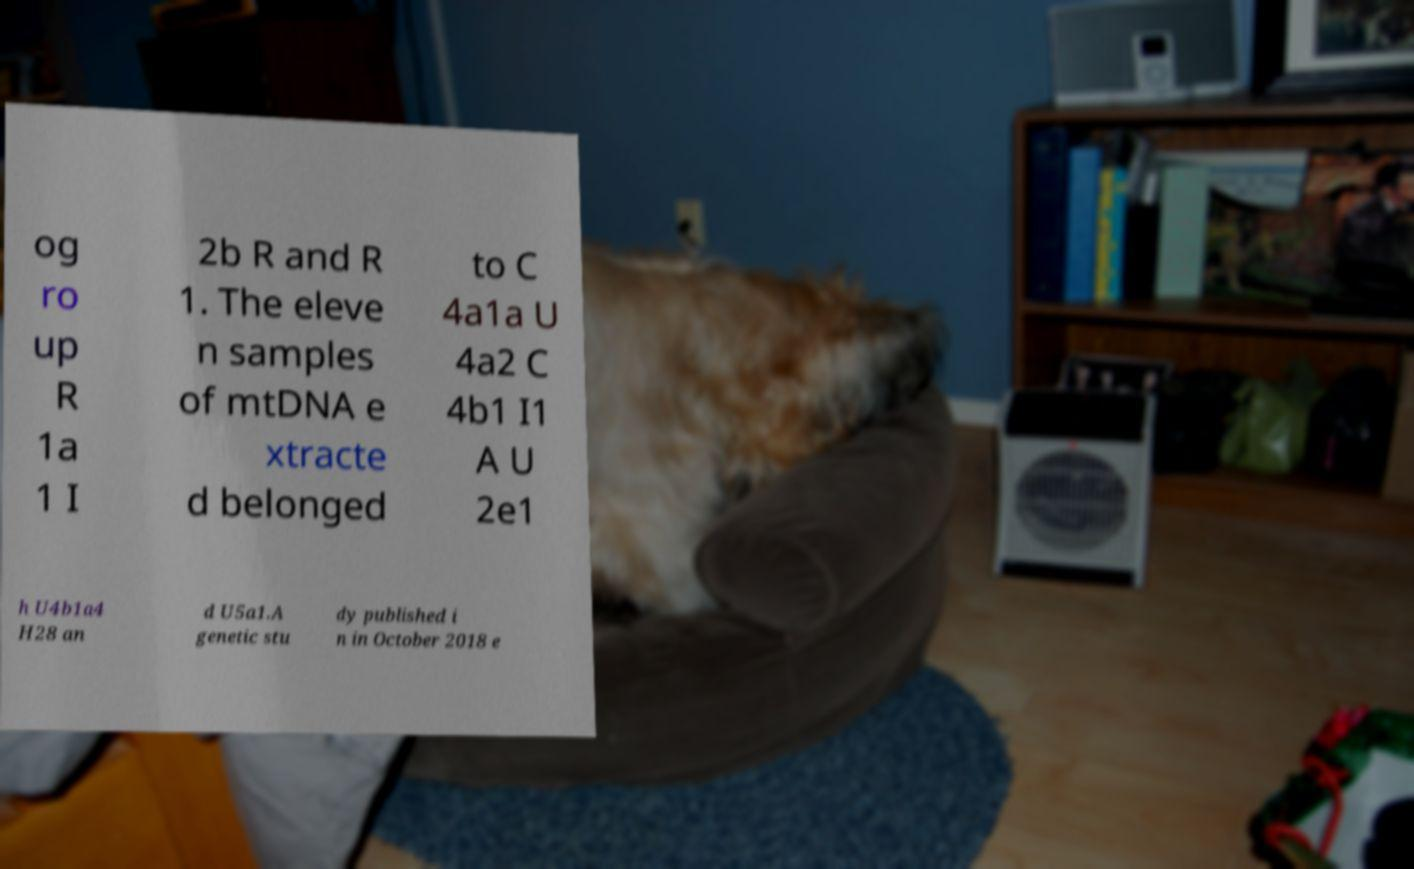Please identify and transcribe the text found in this image. og ro up R 1a 1 I 2b R and R 1. The eleve n samples of mtDNA e xtracte d belonged to C 4a1a U 4a2 C 4b1 I1 A U 2e1 h U4b1a4 H28 an d U5a1.A genetic stu dy published i n in October 2018 e 